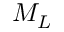<formula> <loc_0><loc_0><loc_500><loc_500>M _ { L }</formula> 